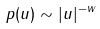<formula> <loc_0><loc_0><loc_500><loc_500>p ( u ) \sim | u | ^ { - w }</formula> 